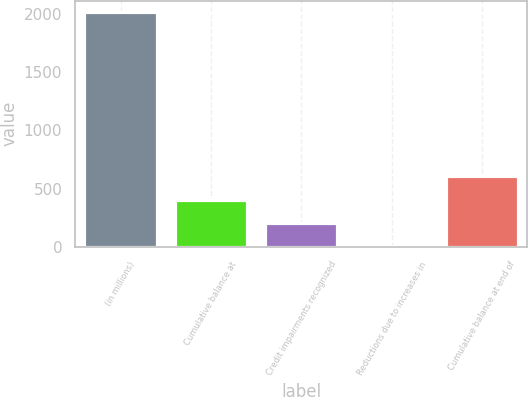Convert chart. <chart><loc_0><loc_0><loc_500><loc_500><bar_chart><fcel>(in millions)<fcel>Cumulative balance at<fcel>Credit impairments recognized<fcel>Reductions due to increases in<fcel>Cumulative balance at end of<nl><fcel>2015<fcel>405.4<fcel>204.2<fcel>3<fcel>606.6<nl></chart> 